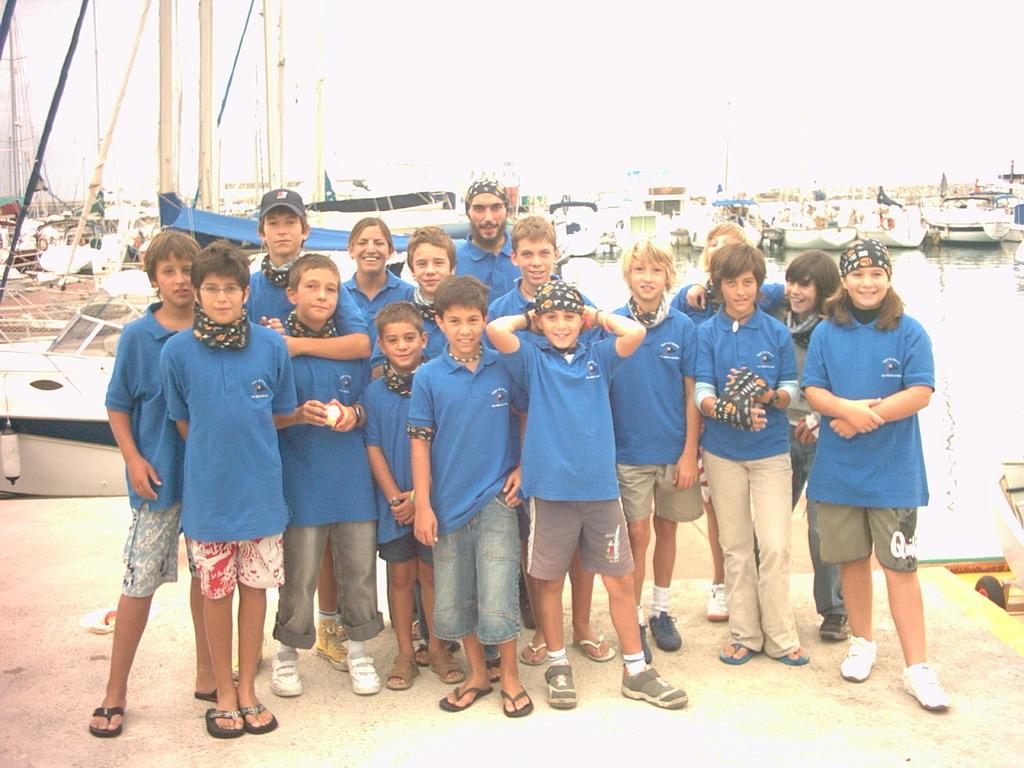What can be seen in the image? There are kids standing in the image. What is visible in the background above the water? There are ships visible in the background. What objects can be seen in the background of the image? There are poles in the background of the image. What part of the natural environment is visible in the image? The sky is visible in the background of the image. Can you see the tongue of the person in the image? There is no indication of a person's tongue in the image, as it features kids standing with ships, poles, and the sky visible in the background. 